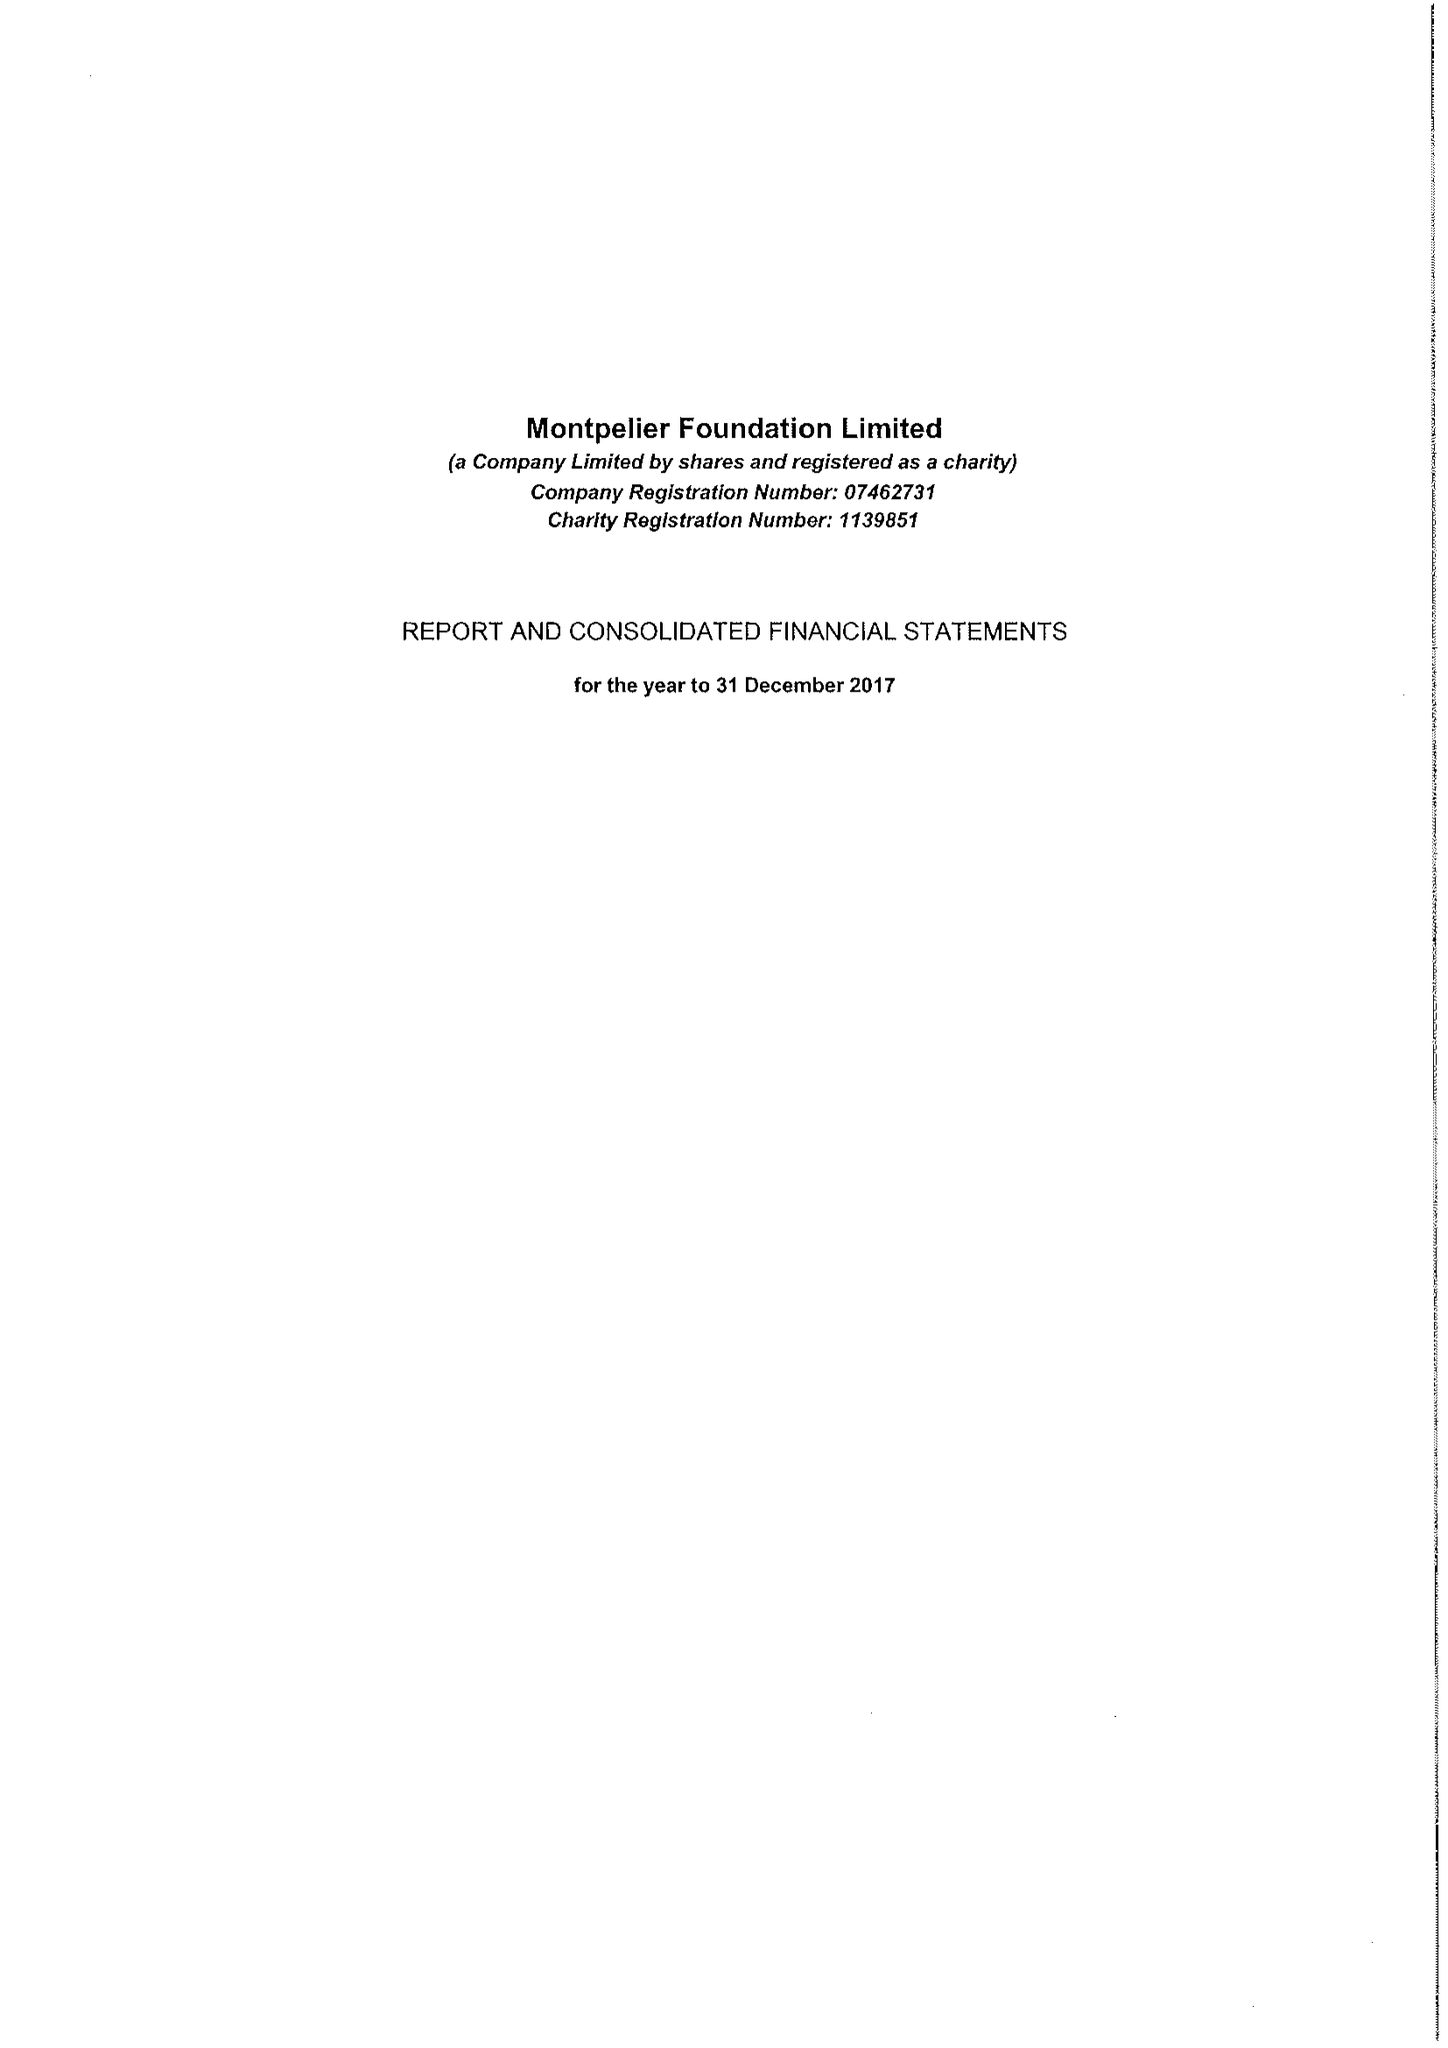What is the value for the charity_number?
Answer the question using a single word or phrase. 1139851 